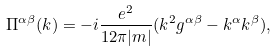<formula> <loc_0><loc_0><loc_500><loc_500>\Pi ^ { \alpha \beta } ( k ) = - i \frac { e ^ { 2 } } { 1 2 \pi | m | } ( k ^ { 2 } g ^ { \alpha \beta } - k ^ { \alpha } k ^ { \beta } ) ,</formula> 